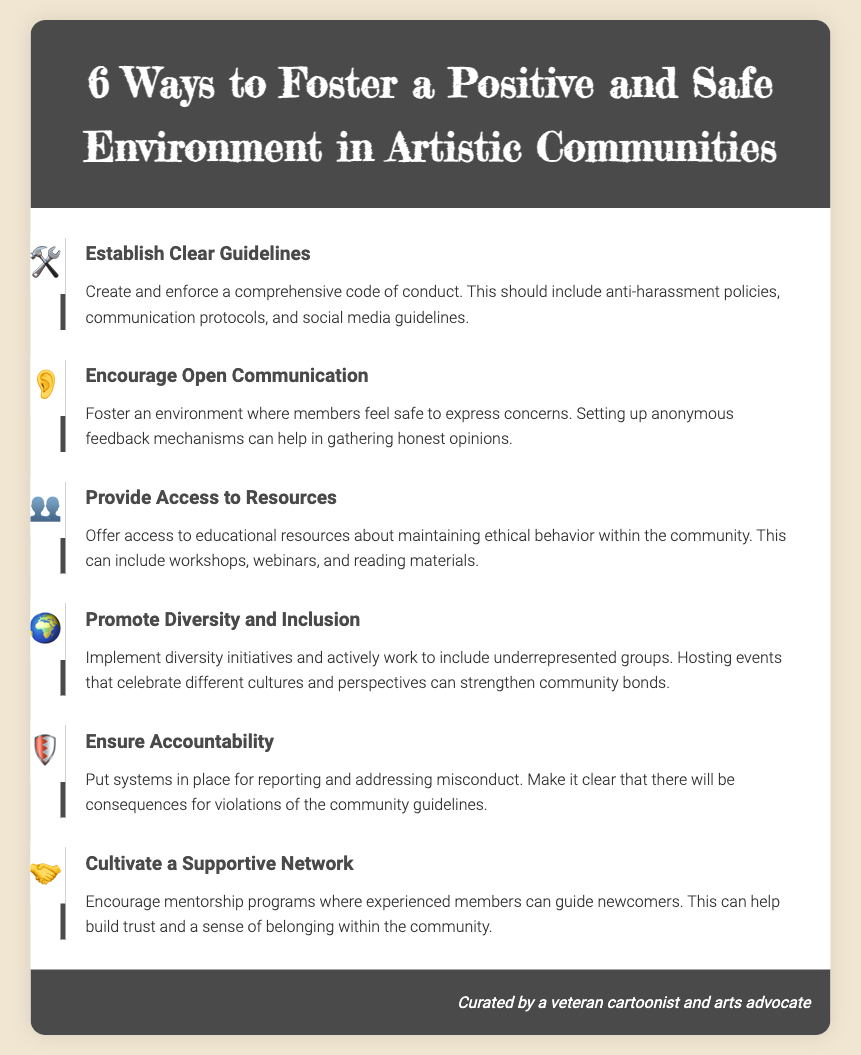What is the first step to foster a positive environment? The first step listed is about establishing clear guidelines which is important for setting the framework for behavior.
Answer: Establish Clear Guidelines How many ways are suggested to create a positive environment? The document lists six specific methods to foster a positive and safe environment in artistic communities.
Answer: Six What should be encouraged among community members? Open communication is emphasized as a crucial element to ensure members can express concerns.
Answer: Open Communication Which step addresses reporting misconduct? The step that ensures consequences for violations of community guidelines directly addresses the need for reporting misconduct.
Answer: Ensure Accountability What initiative should be implemented to support diversity? The step suggests implementing diversity initiatives to promote inclusivity within the community.
Answer: Diversity Initiatives What type of programs should community leaders encourage? Mentorship programs are mentioned as a way for experienced members to support newcomers in the community.
Answer: Mentorship Programs 